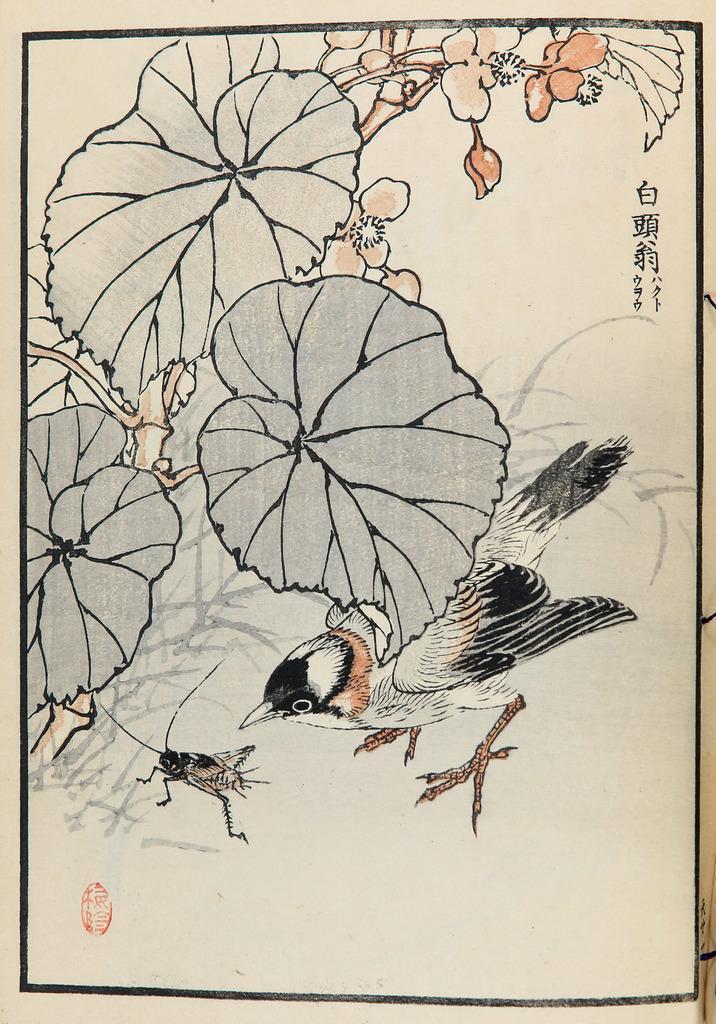In one or two sentences, can you explain what this image depicts? In this picture we can see a painting of a bird, insect, leaves, flowers. 